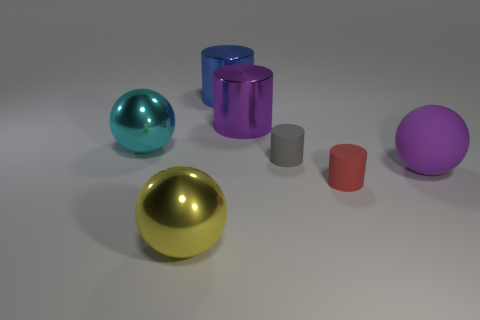What is the yellow object made of?
Offer a very short reply. Metal. What number of balls are cyan metallic objects or yellow objects?
Make the answer very short. 2. Are the tiny gray cylinder and the big yellow thing made of the same material?
Your answer should be compact. No. What is the size of the blue thing that is the same shape as the large purple shiny object?
Provide a succinct answer. Large. What material is the big object that is on the right side of the large blue metal cylinder and in front of the large cyan thing?
Your answer should be very brief. Rubber. Are there an equal number of big yellow shiny spheres that are behind the purple cylinder and large balls?
Make the answer very short. No. How many things are either metal objects that are in front of the blue metallic object or tiny red matte cylinders?
Offer a very short reply. 4. Do the big metallic thing that is to the left of the yellow metal ball and the rubber sphere have the same color?
Provide a succinct answer. No. How big is the purple object behind the cyan shiny object?
Your answer should be compact. Large. The shiny thing to the left of the sphere that is in front of the purple rubber ball is what shape?
Your answer should be compact. Sphere. 